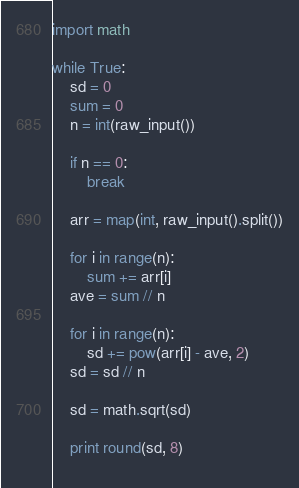<code> <loc_0><loc_0><loc_500><loc_500><_Python_>import math

while True:
    sd = 0
    sum = 0
    n = int(raw_input())

    if n == 0:
        break

    arr = map(int, raw_input().split())
    
    for i in range(n):
        sum += arr[i]
    ave = sum // n

    for i in range(n):
        sd += pow(arr[i] - ave, 2)
    sd = sd // n

    sd = math.sqrt(sd)

    print round(sd, 8)
    </code> 